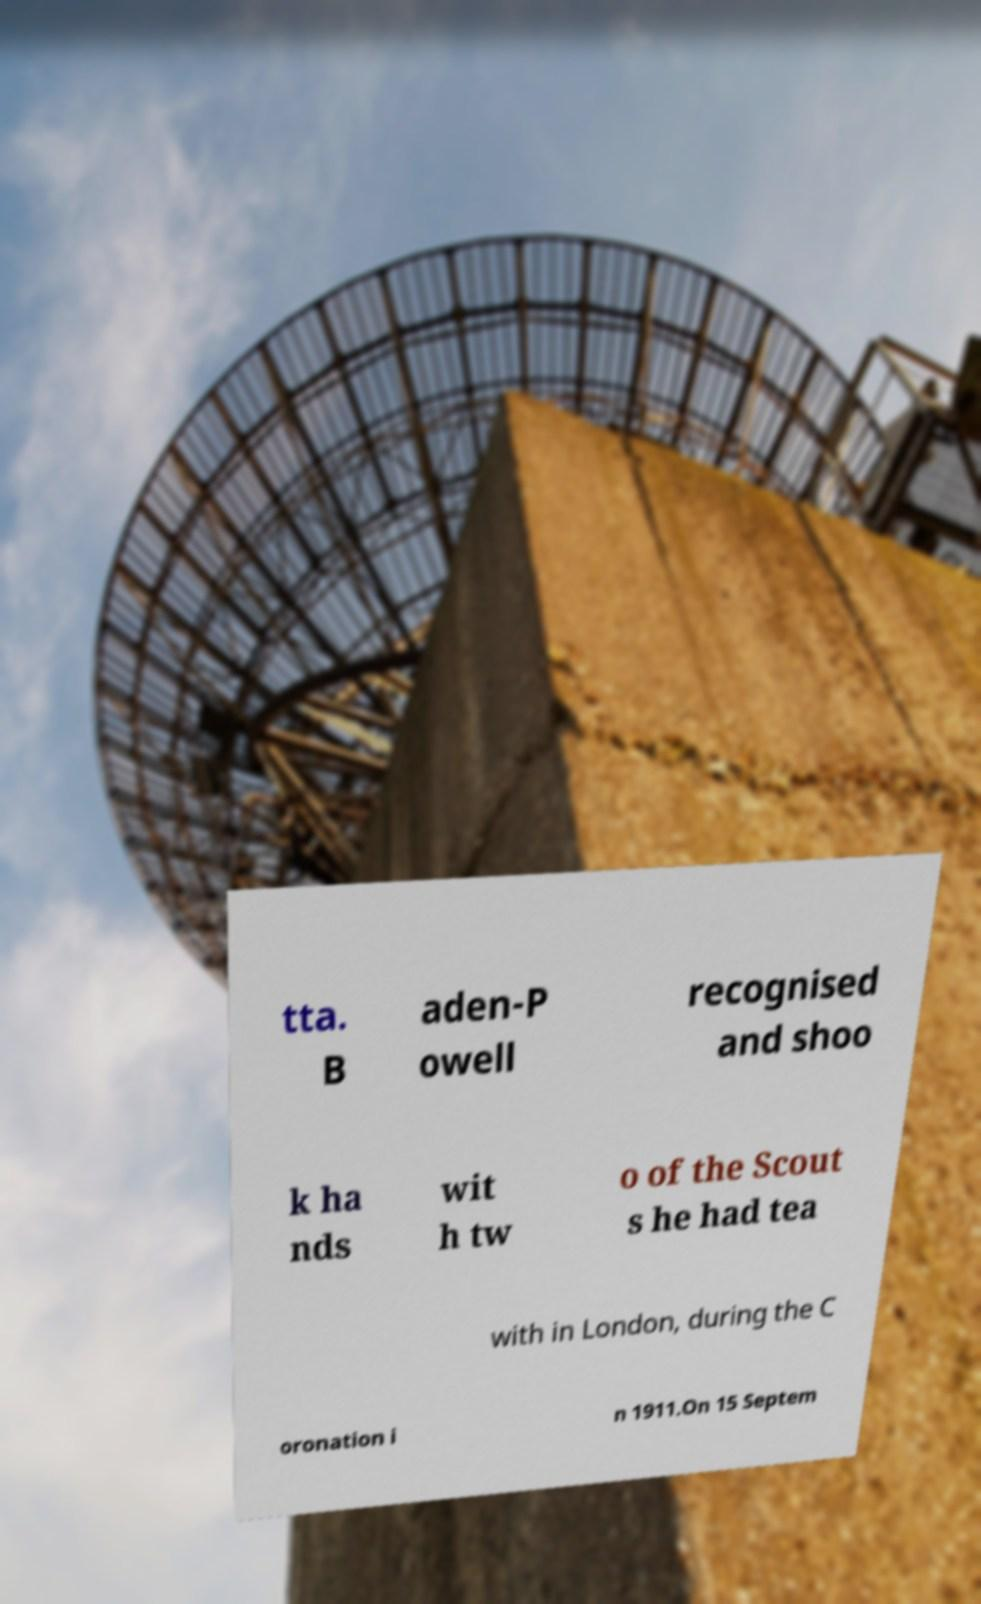Can you accurately transcribe the text from the provided image for me? tta. B aden-P owell recognised and shoo k ha nds wit h tw o of the Scout s he had tea with in London, during the C oronation i n 1911.On 15 Septem 